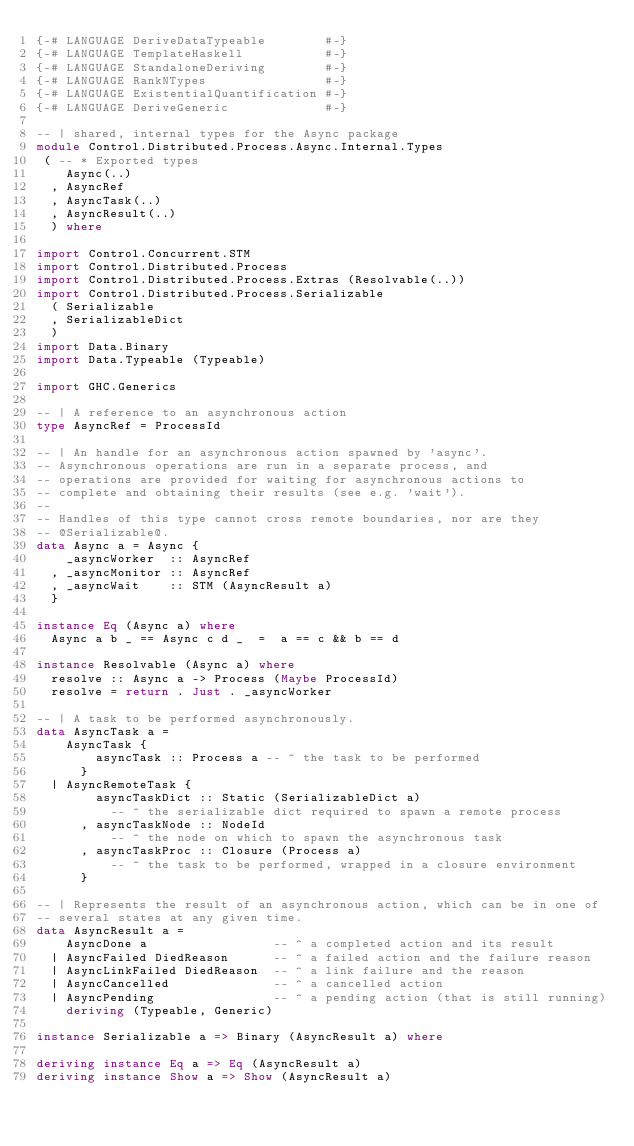<code> <loc_0><loc_0><loc_500><loc_500><_Haskell_>{-# LANGUAGE DeriveDataTypeable        #-}
{-# LANGUAGE TemplateHaskell           #-}
{-# LANGUAGE StandaloneDeriving        #-}
{-# LANGUAGE RankNTypes                #-}
{-# LANGUAGE ExistentialQuantification #-}
{-# LANGUAGE DeriveGeneric             #-}

-- | shared, internal types for the Async package
module Control.Distributed.Process.Async.Internal.Types
 ( -- * Exported types
    Async(..)
  , AsyncRef
  , AsyncTask(..)
  , AsyncResult(..)
  ) where

import Control.Concurrent.STM
import Control.Distributed.Process
import Control.Distributed.Process.Extras (Resolvable(..))
import Control.Distributed.Process.Serializable
  ( Serializable
  , SerializableDict
  )
import Data.Binary
import Data.Typeable (Typeable)

import GHC.Generics

-- | A reference to an asynchronous action
type AsyncRef = ProcessId

-- | An handle for an asynchronous action spawned by 'async'.
-- Asynchronous operations are run in a separate process, and
-- operations are provided for waiting for asynchronous actions to
-- complete and obtaining their results (see e.g. 'wait').
--
-- Handles of this type cannot cross remote boundaries, nor are they
-- @Serializable@.
data Async a = Async {
    _asyncWorker  :: AsyncRef
  , _asyncMonitor :: AsyncRef
  , _asyncWait    :: STM (AsyncResult a)
  }

instance Eq (Async a) where
  Async a b _ == Async c d _  =  a == c && b == d

instance Resolvable (Async a) where
  resolve :: Async a -> Process (Maybe ProcessId)
  resolve = return . Just . _asyncWorker

-- | A task to be performed asynchronously.
data AsyncTask a =
    AsyncTask {
        asyncTask :: Process a -- ^ the task to be performed
      }
  | AsyncRemoteTask {
        asyncTaskDict :: Static (SerializableDict a)
          -- ^ the serializable dict required to spawn a remote process
      , asyncTaskNode :: NodeId
          -- ^ the node on which to spawn the asynchronous task
      , asyncTaskProc :: Closure (Process a)
          -- ^ the task to be performed, wrapped in a closure environment
      }

-- | Represents the result of an asynchronous action, which can be in one of
-- several states at any given time.
data AsyncResult a =
    AsyncDone a                 -- ^ a completed action and its result
  | AsyncFailed DiedReason      -- ^ a failed action and the failure reason
  | AsyncLinkFailed DiedReason  -- ^ a link failure and the reason
  | AsyncCancelled              -- ^ a cancelled action
  | AsyncPending                -- ^ a pending action (that is still running)
    deriving (Typeable, Generic)

instance Serializable a => Binary (AsyncResult a) where

deriving instance Eq a => Eq (AsyncResult a)
deriving instance Show a => Show (AsyncResult a)

</code> 